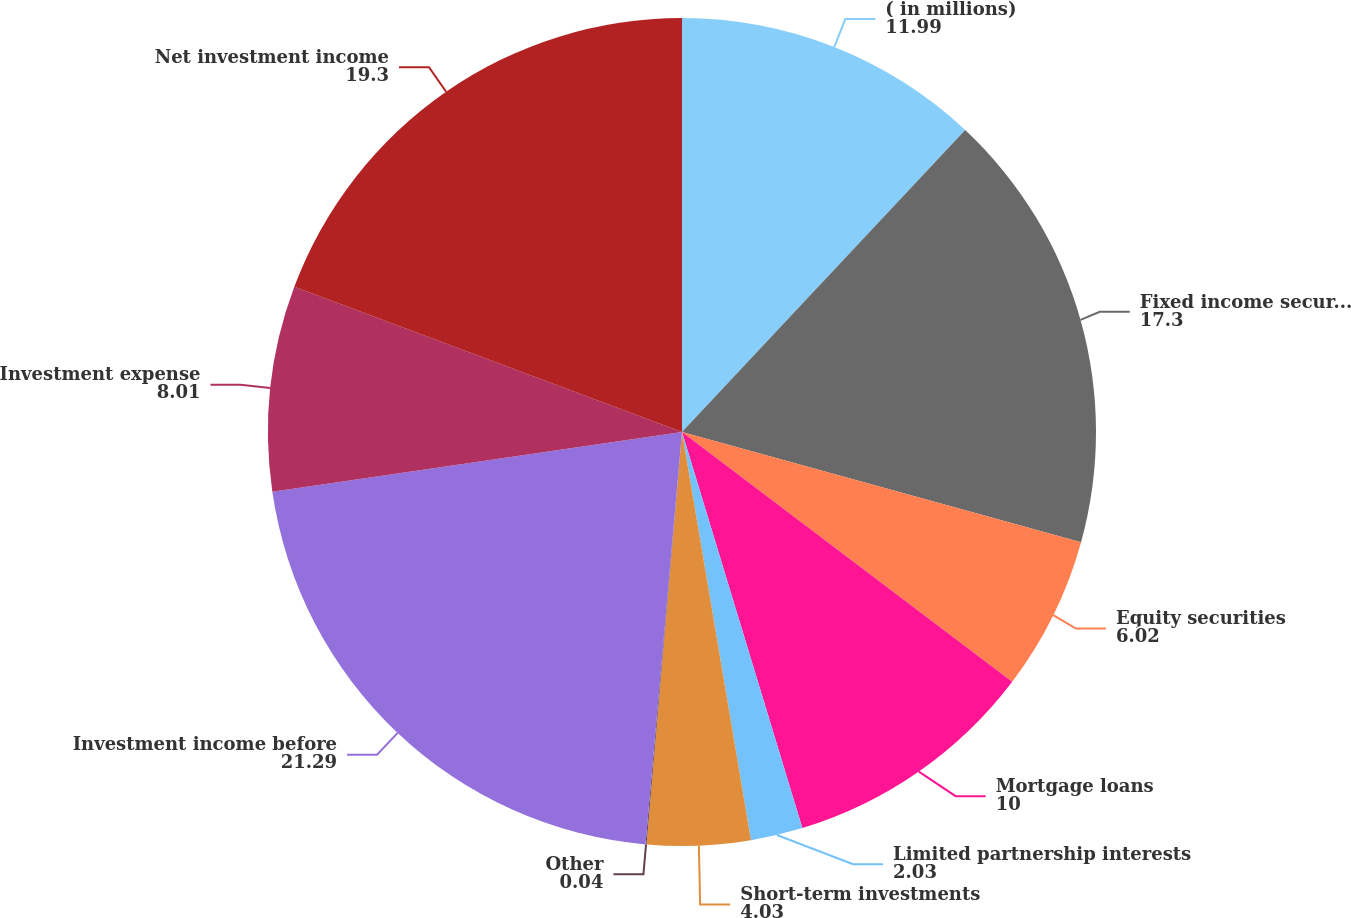<chart> <loc_0><loc_0><loc_500><loc_500><pie_chart><fcel>( in millions)<fcel>Fixed income securities<fcel>Equity securities<fcel>Mortgage loans<fcel>Limited partnership interests<fcel>Short-term investments<fcel>Other<fcel>Investment income before<fcel>Investment expense<fcel>Net investment income<nl><fcel>11.99%<fcel>17.3%<fcel>6.02%<fcel>10.0%<fcel>2.03%<fcel>4.03%<fcel>0.04%<fcel>21.29%<fcel>8.01%<fcel>19.3%<nl></chart> 